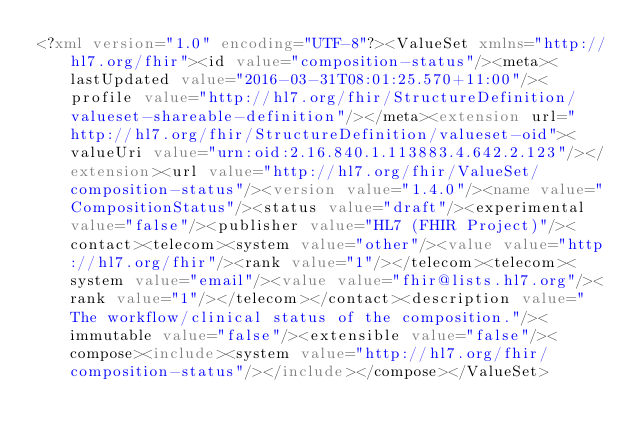Convert code to text. <code><loc_0><loc_0><loc_500><loc_500><_XML_><?xml version="1.0" encoding="UTF-8"?><ValueSet xmlns="http://hl7.org/fhir"><id value="composition-status"/><meta><lastUpdated value="2016-03-31T08:01:25.570+11:00"/><profile value="http://hl7.org/fhir/StructureDefinition/valueset-shareable-definition"/></meta><extension url="http://hl7.org/fhir/StructureDefinition/valueset-oid"><valueUri value="urn:oid:2.16.840.1.113883.4.642.2.123"/></extension><url value="http://hl7.org/fhir/ValueSet/composition-status"/><version value="1.4.0"/><name value="CompositionStatus"/><status value="draft"/><experimental value="false"/><publisher value="HL7 (FHIR Project)"/><contact><telecom><system value="other"/><value value="http://hl7.org/fhir"/><rank value="1"/></telecom><telecom><system value="email"/><value value="fhir@lists.hl7.org"/><rank value="1"/></telecom></contact><description value="The workflow/clinical status of the composition."/><immutable value="false"/><extensible value="false"/><compose><include><system value="http://hl7.org/fhir/composition-status"/></include></compose></ValueSet></code> 